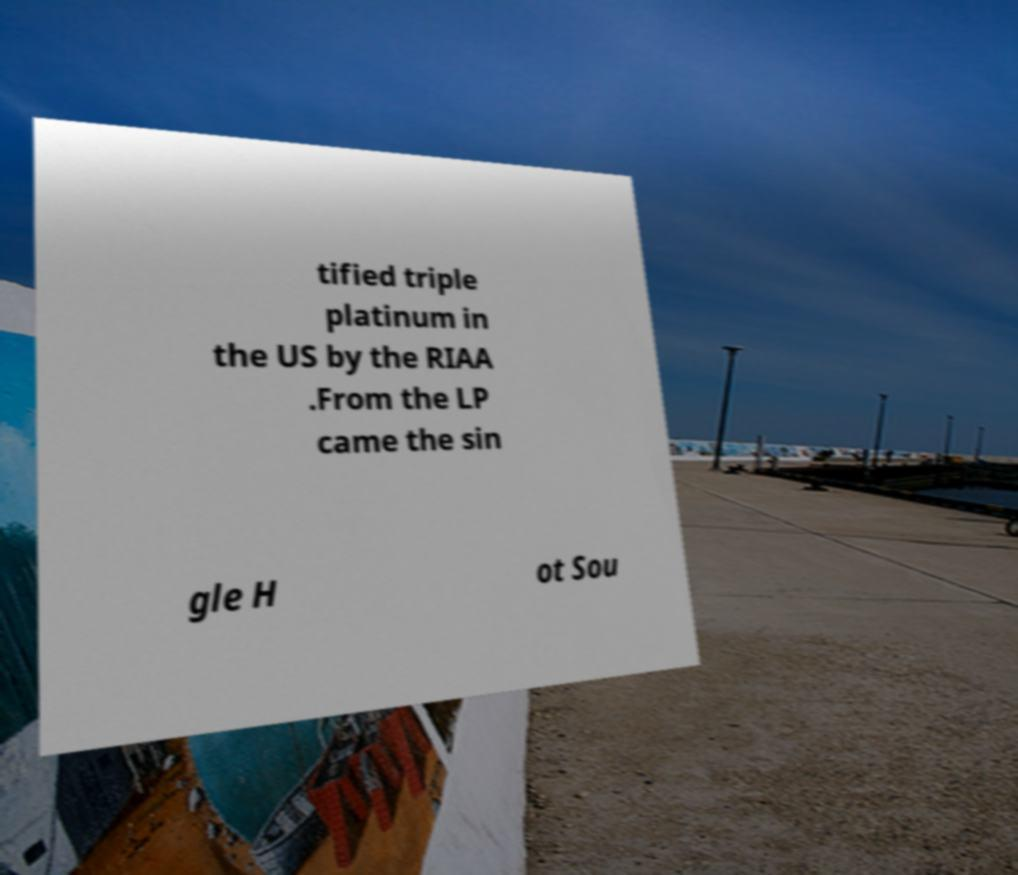I need the written content from this picture converted into text. Can you do that? tified triple platinum in the US by the RIAA .From the LP came the sin gle H ot Sou 